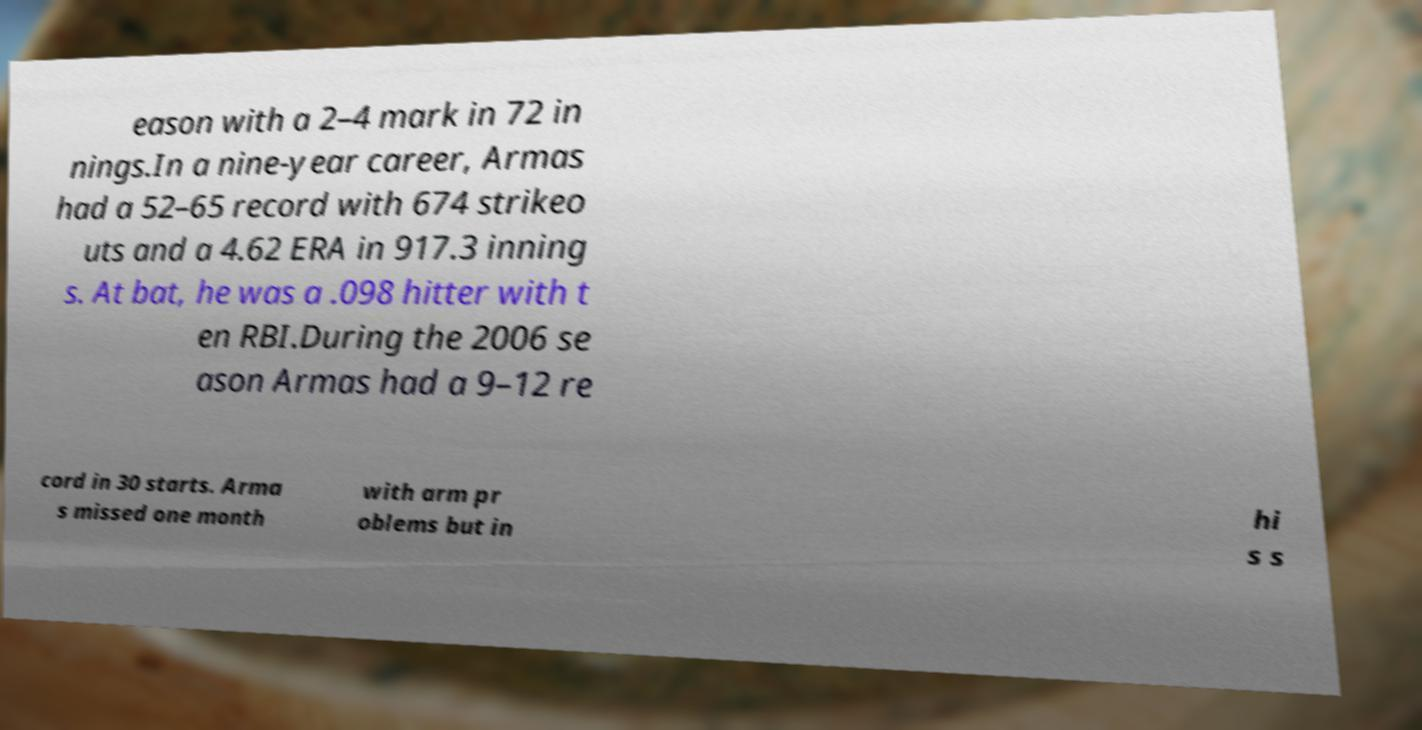There's text embedded in this image that I need extracted. Can you transcribe it verbatim? eason with a 2–4 mark in 72 in nings.In a nine-year career, Armas had a 52–65 record with 674 strikeo uts and a 4.62 ERA in 917.3 inning s. At bat, he was a .098 hitter with t en RBI.During the 2006 se ason Armas had a 9–12 re cord in 30 starts. Arma s missed one month with arm pr oblems but in hi s s 